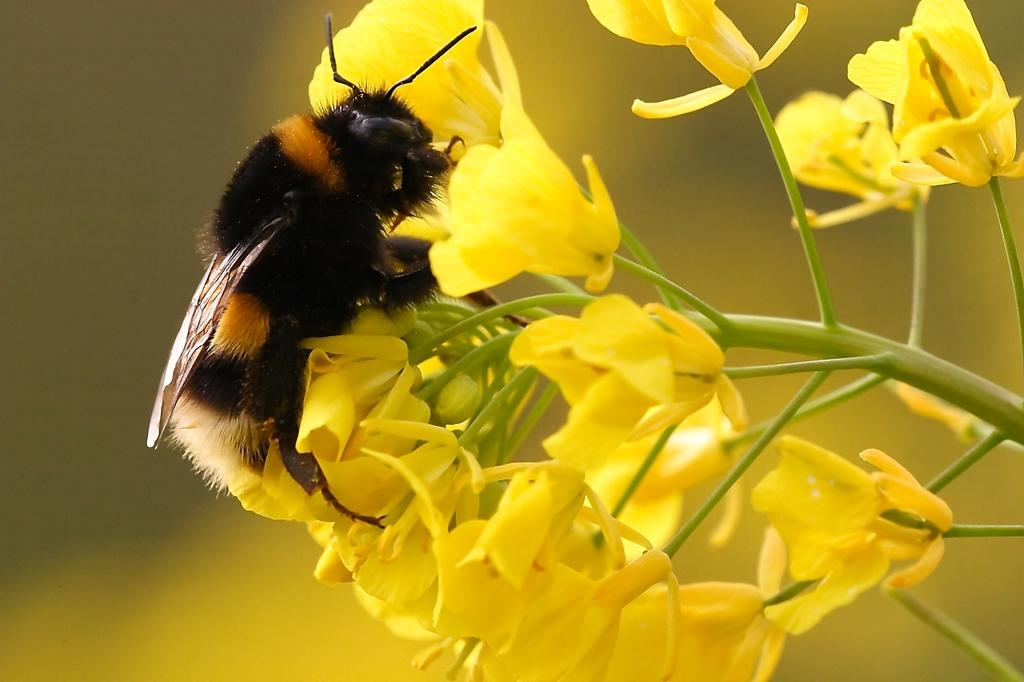What type of insect is in the image? There is a honey bee in the image. What is the honey bee doing in the image? The honey bee is on yellow flowers. Can you describe the background of the image? The background of the image is blurred. How many legs does the shop have in the image? There is no shop present in the image, so it is not possible to determine how many legs it might have. 